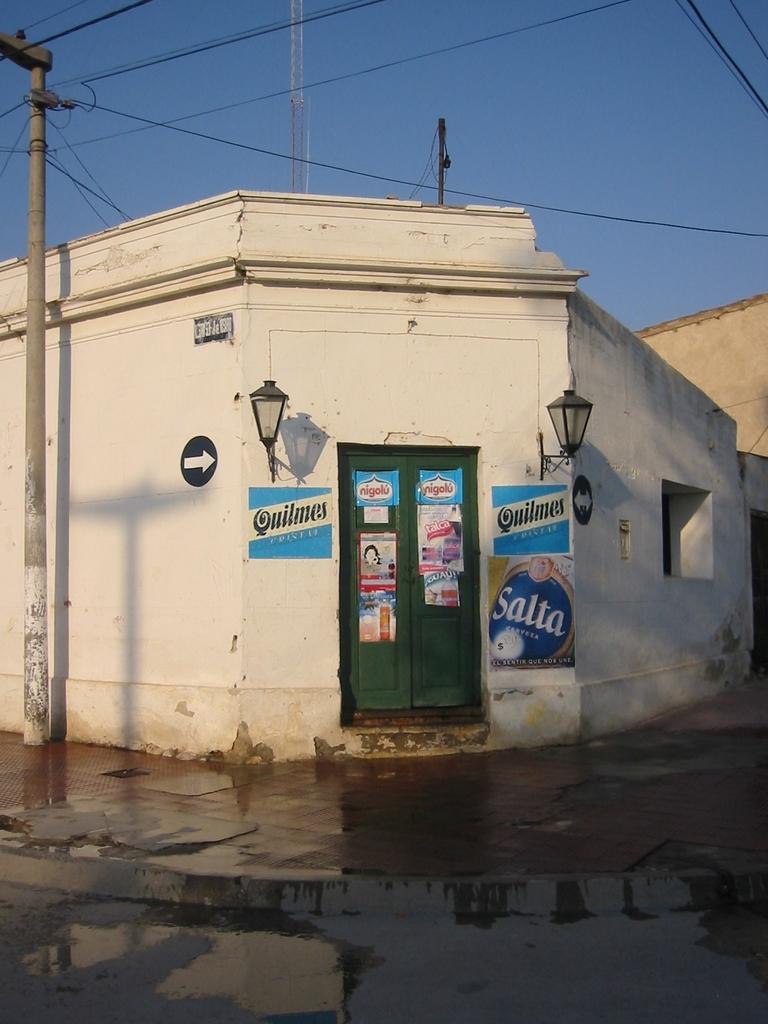Can you describe this image briefly? In this image I can see a building with doors and two lamps, some sign boards and stickers on the wall and doors with some text. I can see a pole with some electrical wires on the left hand side. I can see another pole at the top of the image. At the bottom of the image I can see some water on the ground 